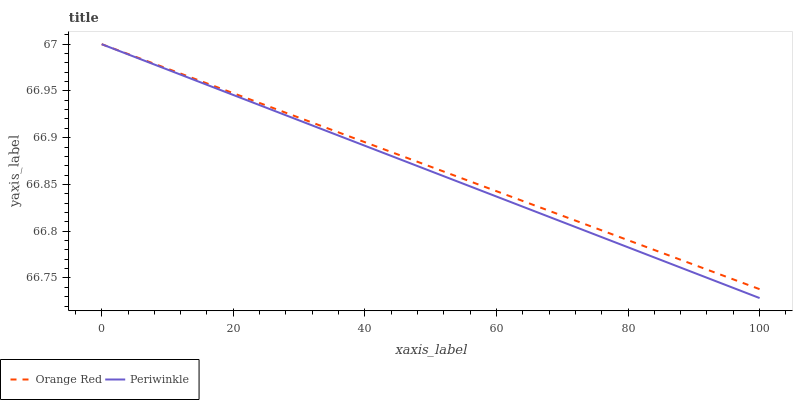Does Periwinkle have the minimum area under the curve?
Answer yes or no. Yes. Does Orange Red have the maximum area under the curve?
Answer yes or no. Yes. Does Orange Red have the minimum area under the curve?
Answer yes or no. No. Is Periwinkle the smoothest?
Answer yes or no. Yes. Is Orange Red the roughest?
Answer yes or no. Yes. Is Orange Red the smoothest?
Answer yes or no. No. Does Periwinkle have the lowest value?
Answer yes or no. Yes. Does Orange Red have the lowest value?
Answer yes or no. No. Does Orange Red have the highest value?
Answer yes or no. Yes. Does Orange Red intersect Periwinkle?
Answer yes or no. Yes. Is Orange Red less than Periwinkle?
Answer yes or no. No. Is Orange Red greater than Periwinkle?
Answer yes or no. No. 